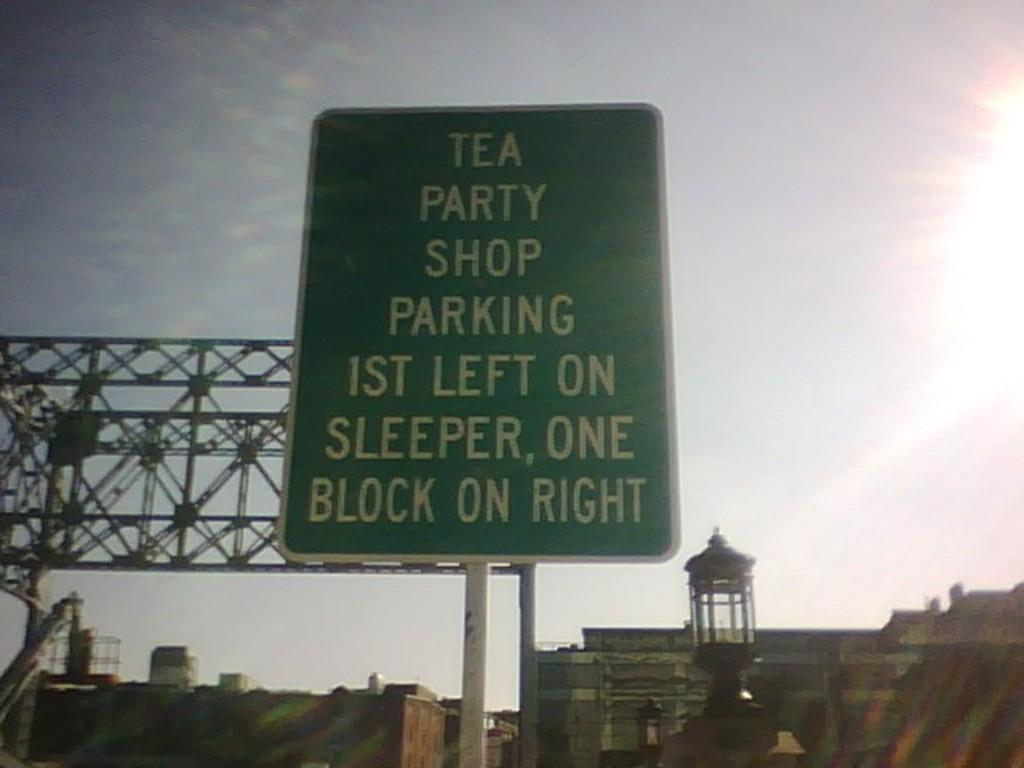<image>
Describe the image concisely. A green sign tells people where to park for the Tea Party Shop. 